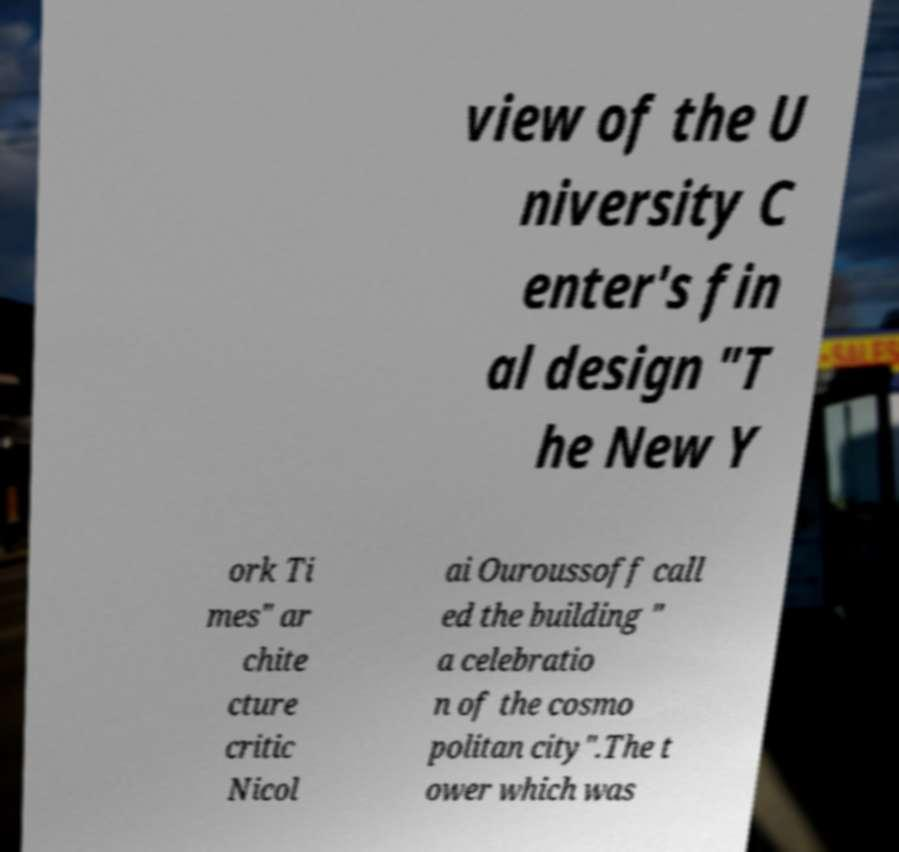Please read and relay the text visible in this image. What does it say? view of the U niversity C enter's fin al design "T he New Y ork Ti mes" ar chite cture critic Nicol ai Ouroussoff call ed the building " a celebratio n of the cosmo politan city".The t ower which was 